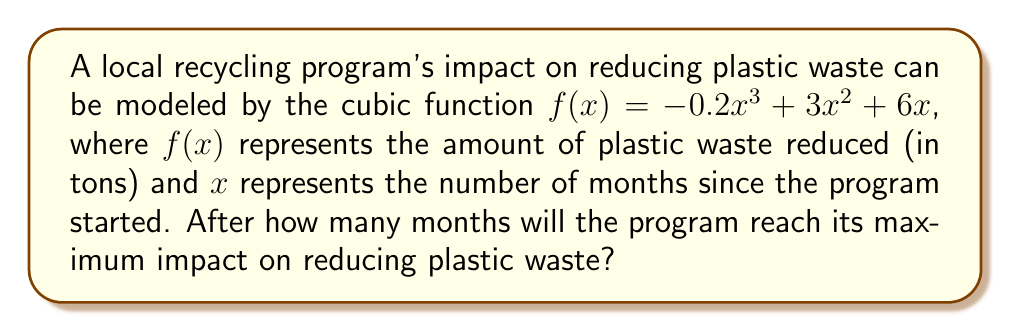Solve this math problem. To find the maximum point of a cubic function, we need to follow these steps:

1) First, we need to find the derivative of the function. The derivative will help us identify where the function's rate of change is zero, which occurs at the maximum and minimum points.

   $f'(x) = -0.6x^2 + 6x + 6$

2) Set the derivative equal to zero and solve for x:

   $-0.6x^2 + 6x + 6 = 0$

3) This is a quadratic equation. We can solve it using the quadratic formula:

   $x = \frac{-b \pm \sqrt{b^2 - 4ac}}{2a}$

   Where $a = -0.6$, $b = 6$, and $c = 6$

4) Plugging these values into the quadratic formula:

   $x = \frac{-6 \pm \sqrt{6^2 - 4(-0.6)(6)}}{2(-0.6)}$

   $= \frac{-6 \pm \sqrt{36 + 14.4}}{-1.2}$

   $= \frac{-6 \pm \sqrt{50.4}}{-1.2}$

   $= \frac{-6 \pm 7.1}{-1.2}$

5) This gives us two solutions:

   $x_1 = \frac{-6 + 7.1}{-1.2} \approx 0.92$

   $x_2 = \frac{-6 - 7.1}{-1.2} \approx 10.92$

6) Since we're looking for the maximum point, and this is a negative cubic function (it opens downward), the larger x-value will give us the maximum point.

7) Since we're dealing with months, we need to round up to the nearest whole number.

Therefore, the program will reach its maximum impact after 11 months.
Answer: 11 months 